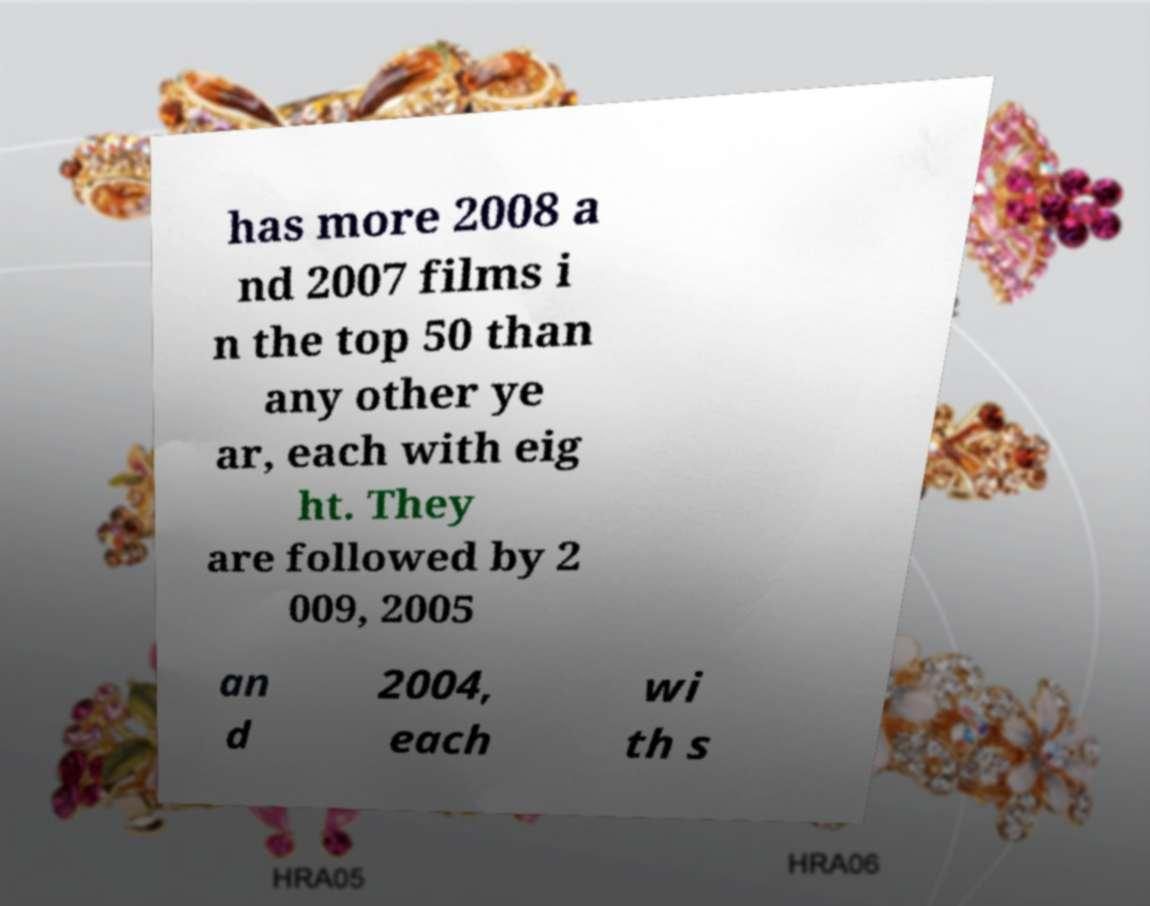Could you assist in decoding the text presented in this image and type it out clearly? has more 2008 a nd 2007 films i n the top 50 than any other ye ar, each with eig ht. They are followed by 2 009, 2005 an d 2004, each wi th s 